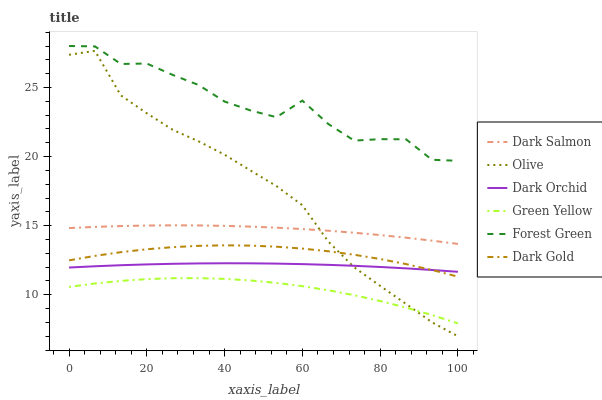Does Green Yellow have the minimum area under the curve?
Answer yes or no. Yes. Does Forest Green have the maximum area under the curve?
Answer yes or no. Yes. Does Dark Salmon have the minimum area under the curve?
Answer yes or no. No. Does Dark Salmon have the maximum area under the curve?
Answer yes or no. No. Is Dark Orchid the smoothest?
Answer yes or no. Yes. Is Forest Green the roughest?
Answer yes or no. Yes. Is Dark Salmon the smoothest?
Answer yes or no. No. Is Dark Salmon the roughest?
Answer yes or no. No. Does Dark Salmon have the lowest value?
Answer yes or no. No. Does Dark Salmon have the highest value?
Answer yes or no. No. Is Green Yellow less than Dark Orchid?
Answer yes or no. Yes. Is Forest Green greater than Olive?
Answer yes or no. Yes. Does Green Yellow intersect Dark Orchid?
Answer yes or no. No. 